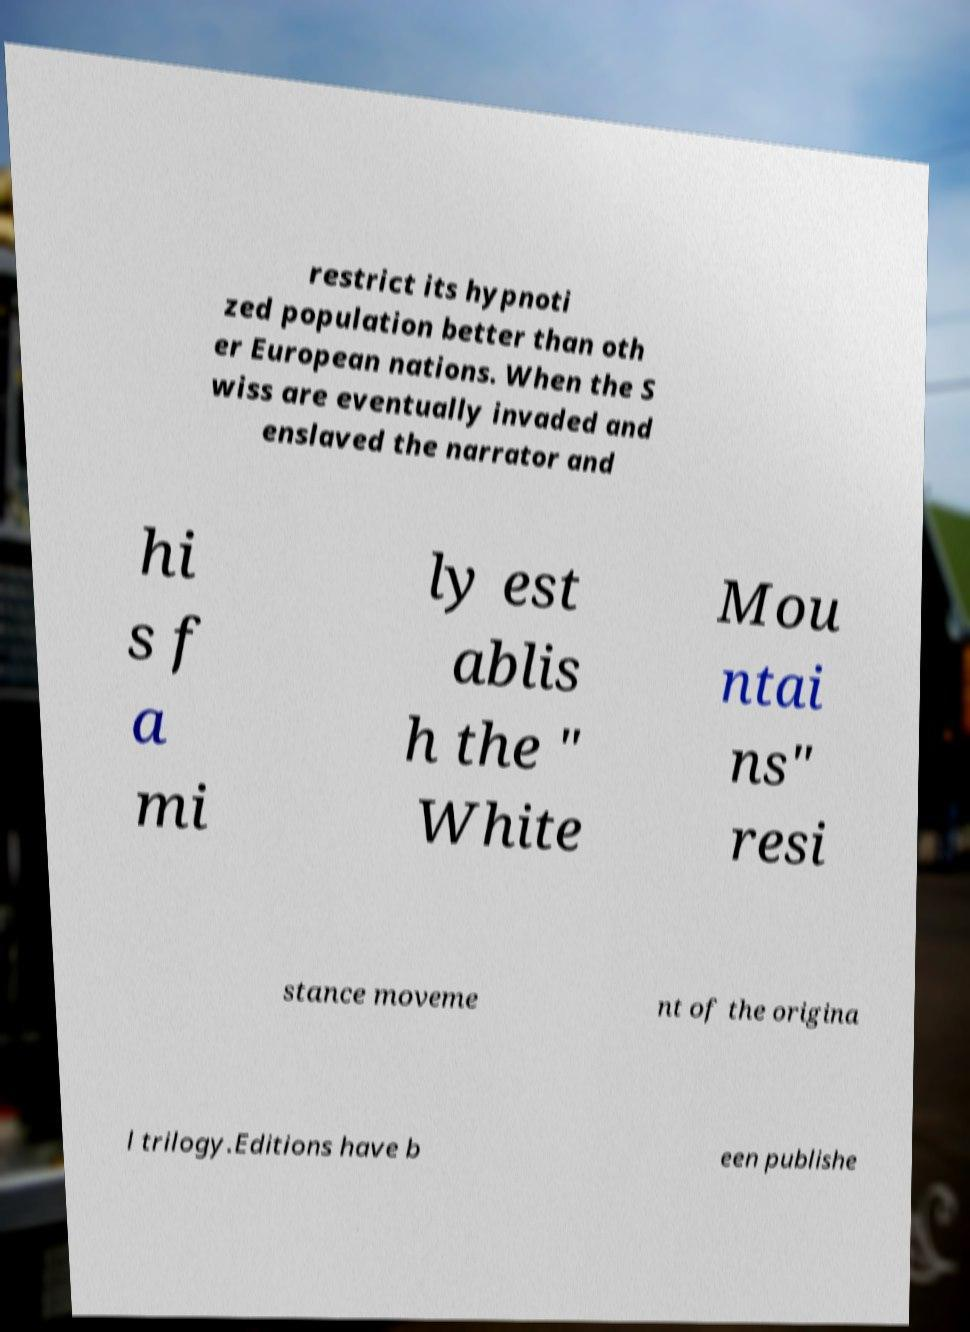For documentation purposes, I need the text within this image transcribed. Could you provide that? restrict its hypnoti zed population better than oth er European nations. When the S wiss are eventually invaded and enslaved the narrator and hi s f a mi ly est ablis h the " White Mou ntai ns" resi stance moveme nt of the origina l trilogy.Editions have b een publishe 